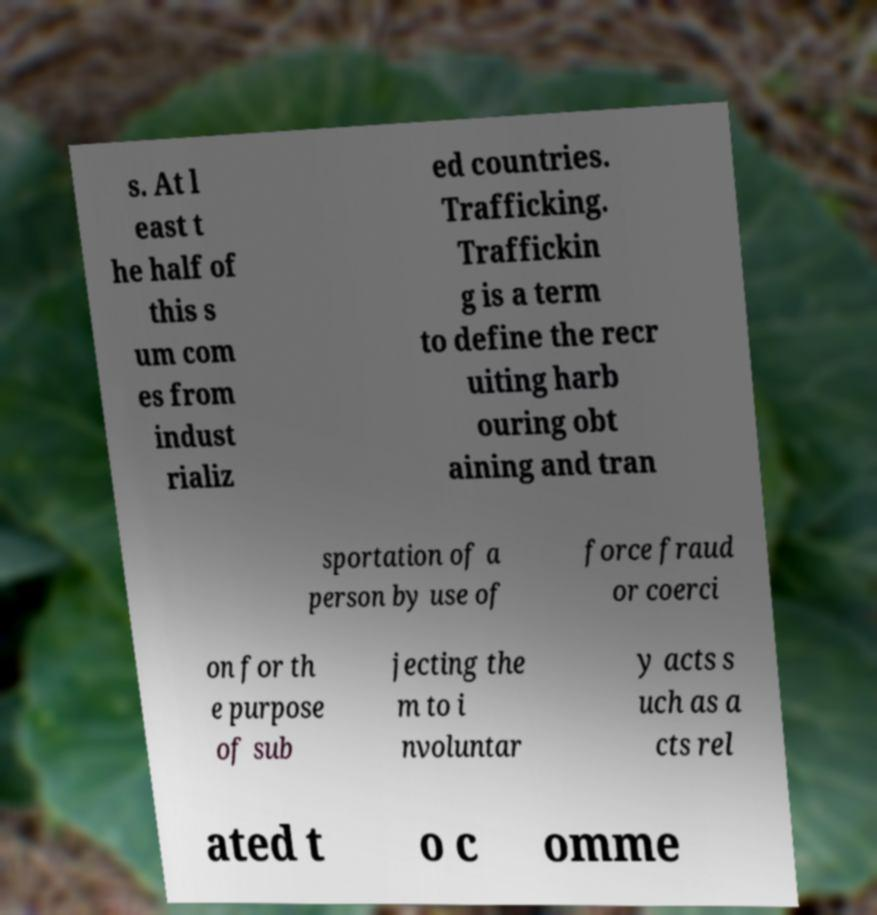Can you read and provide the text displayed in the image?This photo seems to have some interesting text. Can you extract and type it out for me? s. At l east t he half of this s um com es from indust rializ ed countries. Trafficking. Traffickin g is a term to define the recr uiting harb ouring obt aining and tran sportation of a person by use of force fraud or coerci on for th e purpose of sub jecting the m to i nvoluntar y acts s uch as a cts rel ated t o c omme 